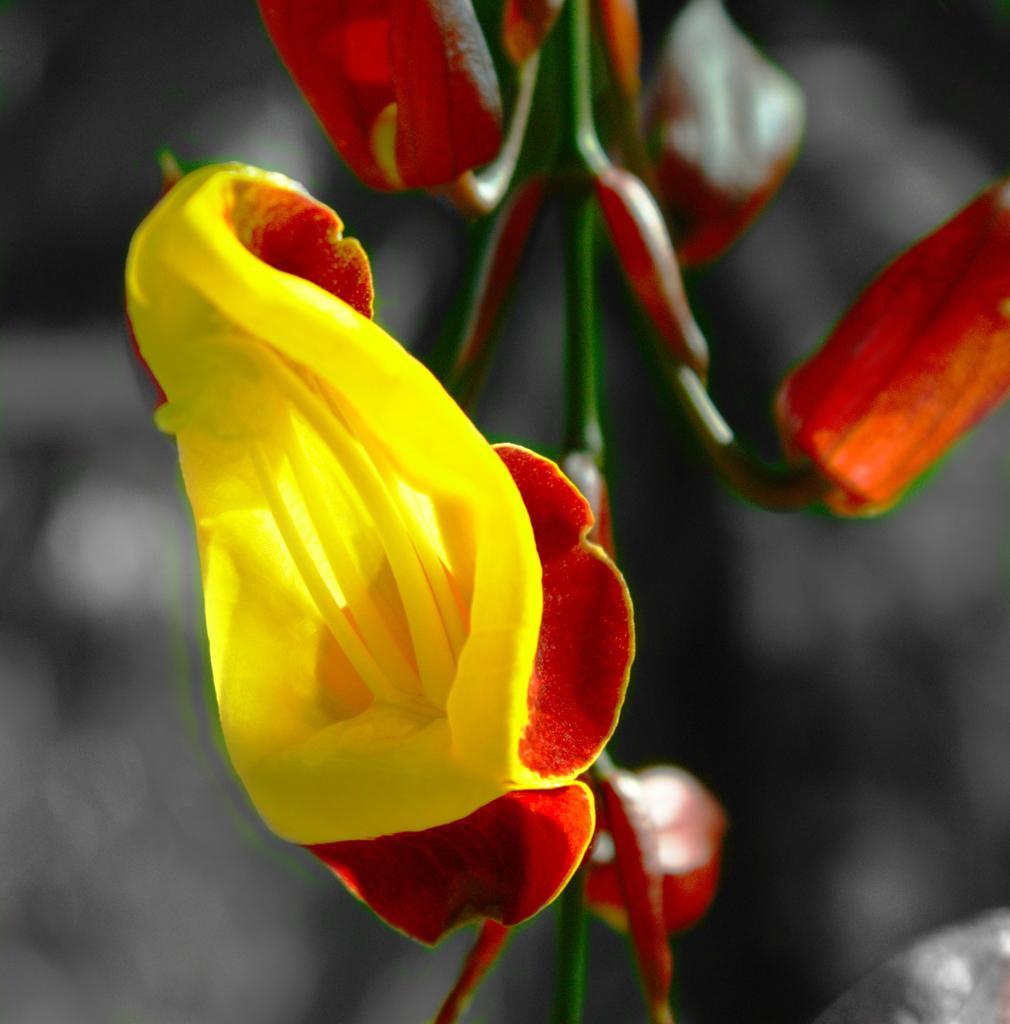Please provide a concise description of this image. In this image, we can see a flower and some buds on the blur background. 